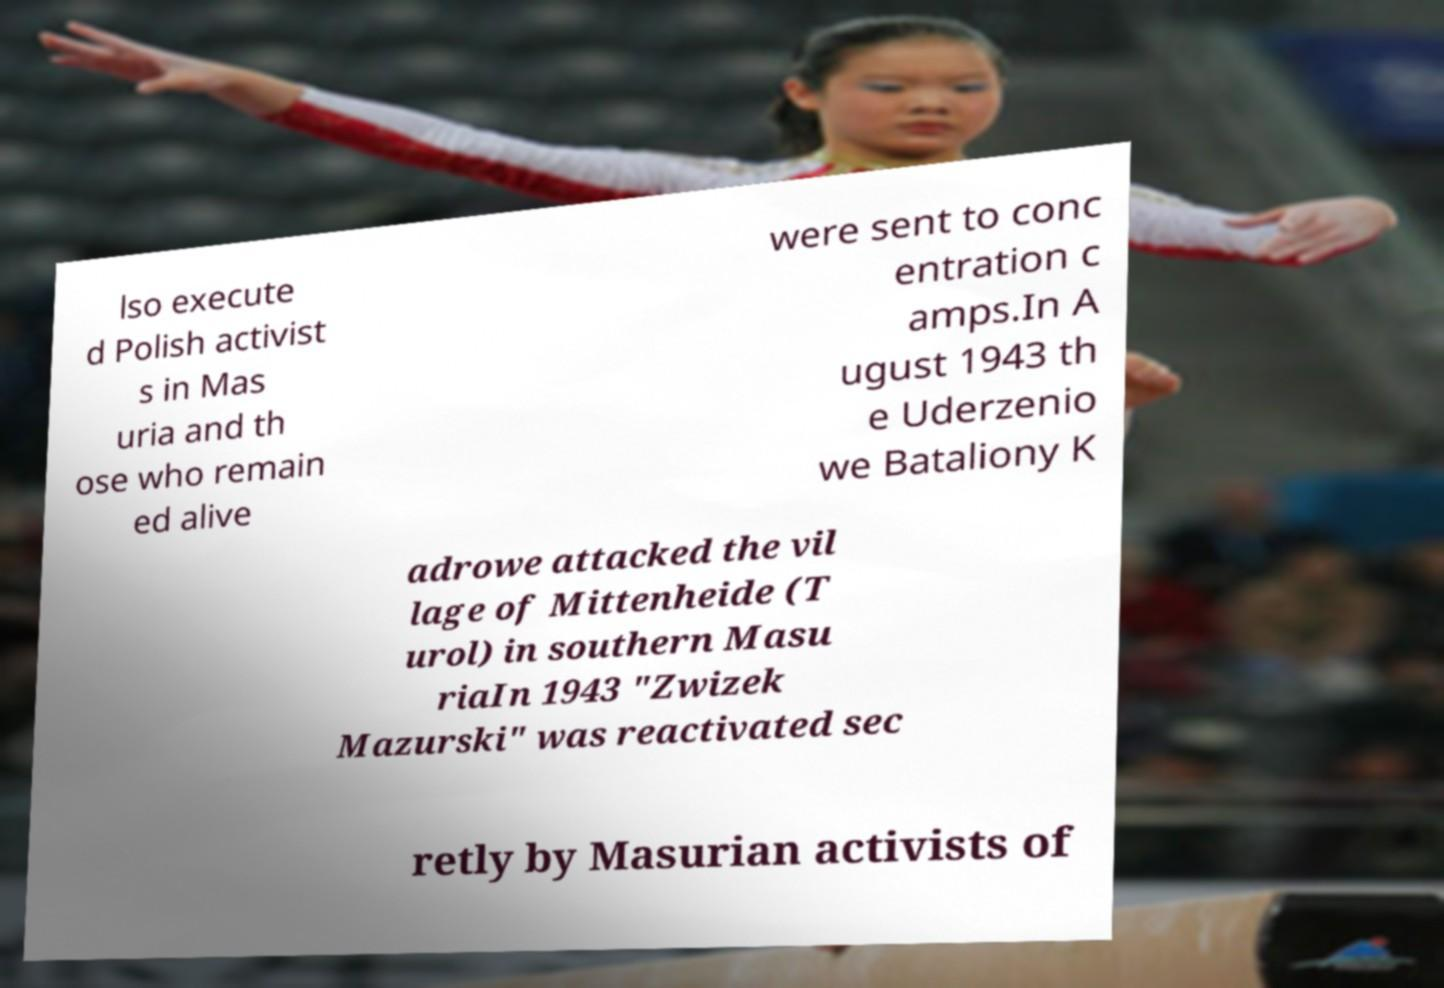For documentation purposes, I need the text within this image transcribed. Could you provide that? lso execute d Polish activist s in Mas uria and th ose who remain ed alive were sent to conc entration c amps.In A ugust 1943 th e Uderzenio we Bataliony K adrowe attacked the vil lage of Mittenheide (T urol) in southern Masu riaIn 1943 "Zwizek Mazurski" was reactivated sec retly by Masurian activists of 